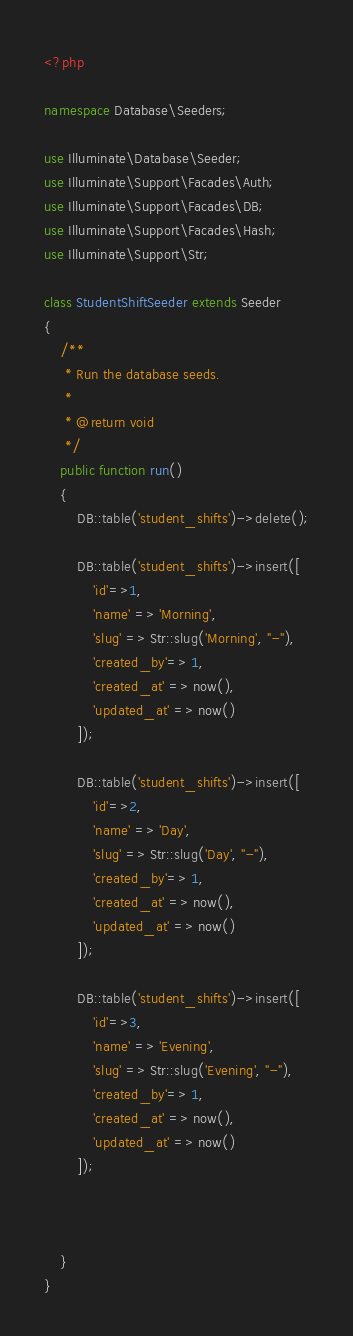<code> <loc_0><loc_0><loc_500><loc_500><_PHP_><?php

namespace Database\Seeders;

use Illuminate\Database\Seeder;
use Illuminate\Support\Facades\Auth;
use Illuminate\Support\Facades\DB;
use Illuminate\Support\Facades\Hash;
use Illuminate\Support\Str;

class StudentShiftSeeder extends Seeder
{
    /**
     * Run the database seeds.
     *
     * @return void
     */
    public function run()
    {
        DB::table('student_shifts')->delete();

        DB::table('student_shifts')->insert([
            'id'=>1,
            'name' => 'Morning',
            'slug' => Str::slug('Morning', "-"),
            'created_by'=> 1,
            'created_at' => now(),
            'updated_at' => now()
        ]);

        DB::table('student_shifts')->insert([
            'id'=>2,
            'name' => 'Day',
            'slug' => Str::slug('Day', "-"),
            'created_by'=> 1,
            'created_at' => now(),
            'updated_at' => now()
        ]);

        DB::table('student_shifts')->insert([
            'id'=>3,
            'name' => 'Evening',
            'slug' => Str::slug('Evening', "-"),
            'created_by'=> 1,
            'created_at' => now(),
            'updated_at' => now()
        ]);


      
    }
}
</code> 